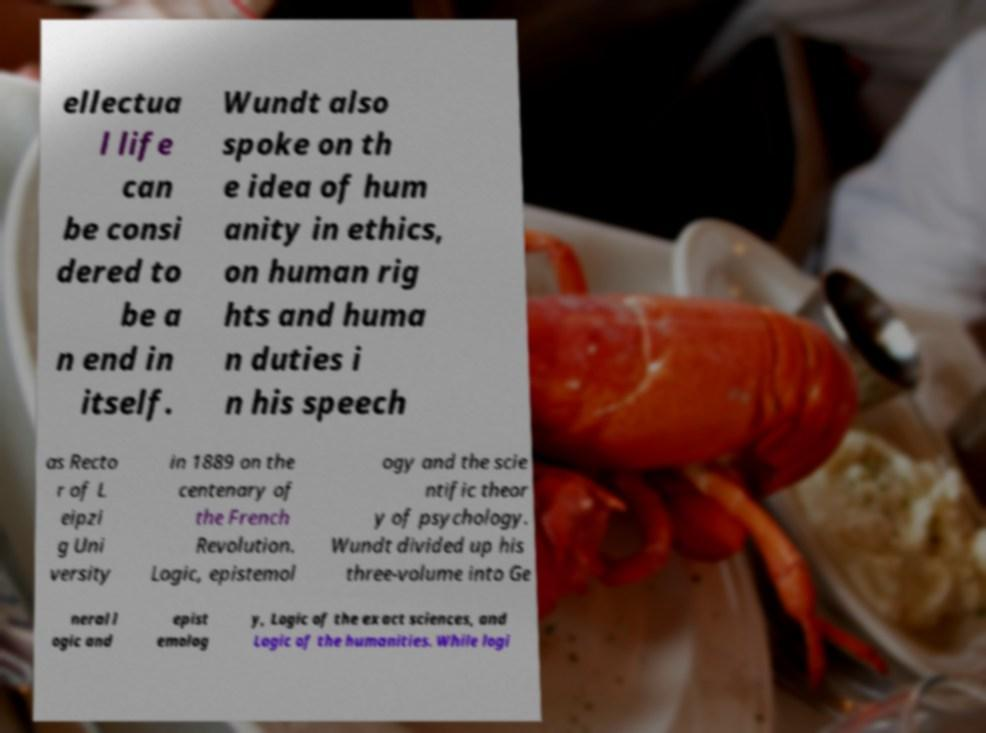Can you read and provide the text displayed in the image?This photo seems to have some interesting text. Can you extract and type it out for me? ellectua l life can be consi dered to be a n end in itself. Wundt also spoke on th e idea of hum anity in ethics, on human rig hts and huma n duties i n his speech as Recto r of L eipzi g Uni versity in 1889 on the centenary of the French Revolution. Logic, epistemol ogy and the scie ntific theor y of psychology. Wundt divided up his three-volume into Ge neral l ogic and epist emolog y, Logic of the exact sciences, and Logic of the humanities. While logi 